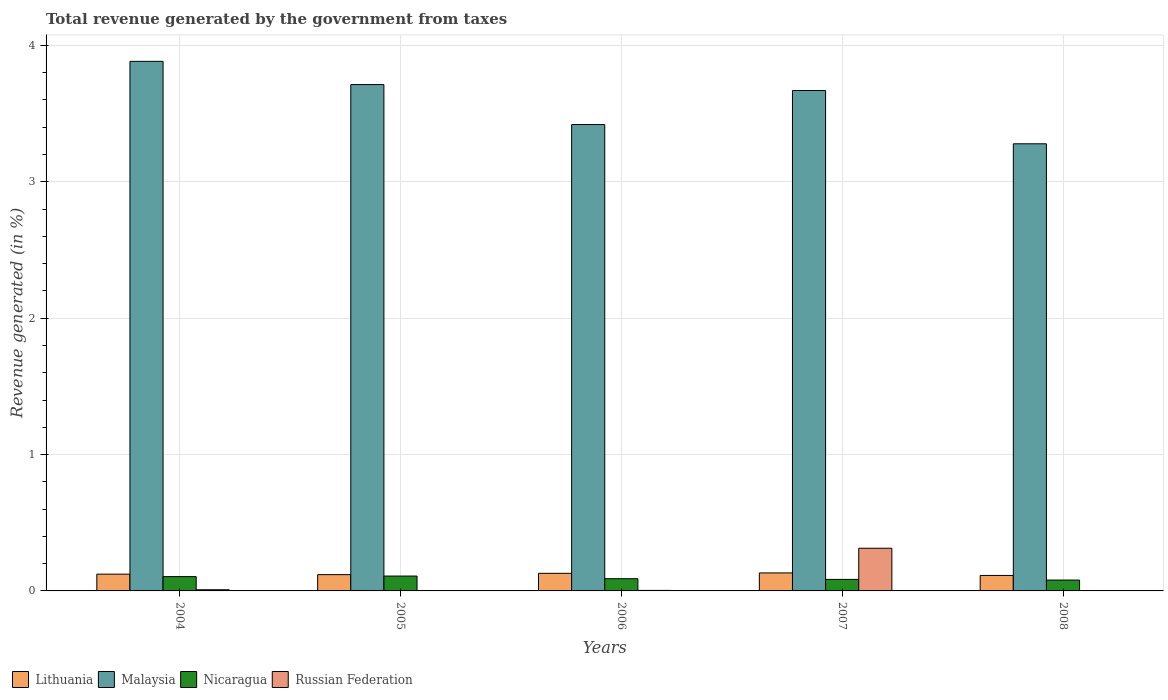How many different coloured bars are there?
Your answer should be very brief. 4. Are the number of bars per tick equal to the number of legend labels?
Your response must be concise. Yes. What is the label of the 1st group of bars from the left?
Your answer should be very brief. 2004. In how many cases, is the number of bars for a given year not equal to the number of legend labels?
Give a very brief answer. 0. What is the total revenue generated in Nicaragua in 2007?
Make the answer very short. 0.08. Across all years, what is the maximum total revenue generated in Russian Federation?
Give a very brief answer. 0.31. Across all years, what is the minimum total revenue generated in Lithuania?
Provide a succinct answer. 0.11. What is the total total revenue generated in Nicaragua in the graph?
Provide a succinct answer. 0.47. What is the difference between the total revenue generated in Lithuania in 2004 and that in 2008?
Your response must be concise. 0.01. What is the difference between the total revenue generated in Russian Federation in 2008 and the total revenue generated in Malaysia in 2007?
Give a very brief answer. -3.67. What is the average total revenue generated in Nicaragua per year?
Offer a terse response. 0.09. In the year 2005, what is the difference between the total revenue generated in Malaysia and total revenue generated in Lithuania?
Give a very brief answer. 3.59. In how many years, is the total revenue generated in Lithuania greater than 1.6 %?
Offer a very short reply. 0. What is the ratio of the total revenue generated in Nicaragua in 2004 to that in 2006?
Your response must be concise. 1.17. Is the difference between the total revenue generated in Malaysia in 2005 and 2007 greater than the difference between the total revenue generated in Lithuania in 2005 and 2007?
Ensure brevity in your answer.  Yes. What is the difference between the highest and the second highest total revenue generated in Lithuania?
Make the answer very short. 0. What is the difference between the highest and the lowest total revenue generated in Lithuania?
Your answer should be very brief. 0.02. In how many years, is the total revenue generated in Nicaragua greater than the average total revenue generated in Nicaragua taken over all years?
Make the answer very short. 2. What does the 3rd bar from the left in 2004 represents?
Ensure brevity in your answer.  Nicaragua. What does the 2nd bar from the right in 2004 represents?
Keep it short and to the point. Nicaragua. How many bars are there?
Your response must be concise. 20. Are all the bars in the graph horizontal?
Give a very brief answer. No. How many years are there in the graph?
Make the answer very short. 5. Are the values on the major ticks of Y-axis written in scientific E-notation?
Your answer should be compact. No. Does the graph contain any zero values?
Make the answer very short. No. Does the graph contain grids?
Your answer should be compact. Yes. Where does the legend appear in the graph?
Provide a succinct answer. Bottom left. How are the legend labels stacked?
Make the answer very short. Horizontal. What is the title of the graph?
Keep it short and to the point. Total revenue generated by the government from taxes. What is the label or title of the X-axis?
Your response must be concise. Years. What is the label or title of the Y-axis?
Give a very brief answer. Revenue generated (in %). What is the Revenue generated (in %) of Lithuania in 2004?
Make the answer very short. 0.12. What is the Revenue generated (in %) in Malaysia in 2004?
Ensure brevity in your answer.  3.88. What is the Revenue generated (in %) of Nicaragua in 2004?
Offer a very short reply. 0.1. What is the Revenue generated (in %) of Russian Federation in 2004?
Your answer should be compact. 0.01. What is the Revenue generated (in %) in Lithuania in 2005?
Give a very brief answer. 0.12. What is the Revenue generated (in %) in Malaysia in 2005?
Give a very brief answer. 3.71. What is the Revenue generated (in %) in Nicaragua in 2005?
Your answer should be compact. 0.11. What is the Revenue generated (in %) in Russian Federation in 2005?
Your answer should be compact. 0. What is the Revenue generated (in %) of Lithuania in 2006?
Give a very brief answer. 0.13. What is the Revenue generated (in %) in Malaysia in 2006?
Ensure brevity in your answer.  3.42. What is the Revenue generated (in %) of Nicaragua in 2006?
Your answer should be compact. 0.09. What is the Revenue generated (in %) of Russian Federation in 2006?
Your response must be concise. 0. What is the Revenue generated (in %) in Lithuania in 2007?
Your answer should be compact. 0.13. What is the Revenue generated (in %) of Malaysia in 2007?
Provide a short and direct response. 3.67. What is the Revenue generated (in %) of Nicaragua in 2007?
Your response must be concise. 0.08. What is the Revenue generated (in %) in Russian Federation in 2007?
Offer a very short reply. 0.31. What is the Revenue generated (in %) in Lithuania in 2008?
Offer a terse response. 0.11. What is the Revenue generated (in %) of Malaysia in 2008?
Provide a short and direct response. 3.28. What is the Revenue generated (in %) of Nicaragua in 2008?
Your answer should be very brief. 0.08. What is the Revenue generated (in %) of Russian Federation in 2008?
Ensure brevity in your answer.  0. Across all years, what is the maximum Revenue generated (in %) in Lithuania?
Make the answer very short. 0.13. Across all years, what is the maximum Revenue generated (in %) of Malaysia?
Provide a short and direct response. 3.88. Across all years, what is the maximum Revenue generated (in %) in Nicaragua?
Give a very brief answer. 0.11. Across all years, what is the maximum Revenue generated (in %) of Russian Federation?
Make the answer very short. 0.31. Across all years, what is the minimum Revenue generated (in %) of Lithuania?
Your response must be concise. 0.11. Across all years, what is the minimum Revenue generated (in %) in Malaysia?
Make the answer very short. 3.28. Across all years, what is the minimum Revenue generated (in %) in Nicaragua?
Your answer should be compact. 0.08. Across all years, what is the minimum Revenue generated (in %) of Russian Federation?
Your answer should be very brief. 0. What is the total Revenue generated (in %) in Lithuania in the graph?
Ensure brevity in your answer.  0.62. What is the total Revenue generated (in %) of Malaysia in the graph?
Keep it short and to the point. 17.96. What is the total Revenue generated (in %) in Nicaragua in the graph?
Give a very brief answer. 0.47. What is the total Revenue generated (in %) of Russian Federation in the graph?
Your answer should be compact. 0.33. What is the difference between the Revenue generated (in %) of Lithuania in 2004 and that in 2005?
Keep it short and to the point. 0. What is the difference between the Revenue generated (in %) in Malaysia in 2004 and that in 2005?
Offer a terse response. 0.17. What is the difference between the Revenue generated (in %) in Nicaragua in 2004 and that in 2005?
Ensure brevity in your answer.  -0. What is the difference between the Revenue generated (in %) of Russian Federation in 2004 and that in 2005?
Ensure brevity in your answer.  0.01. What is the difference between the Revenue generated (in %) of Lithuania in 2004 and that in 2006?
Keep it short and to the point. -0.01. What is the difference between the Revenue generated (in %) of Malaysia in 2004 and that in 2006?
Your answer should be compact. 0.46. What is the difference between the Revenue generated (in %) in Nicaragua in 2004 and that in 2006?
Ensure brevity in your answer.  0.02. What is the difference between the Revenue generated (in %) of Russian Federation in 2004 and that in 2006?
Offer a terse response. 0. What is the difference between the Revenue generated (in %) of Lithuania in 2004 and that in 2007?
Your answer should be very brief. -0.01. What is the difference between the Revenue generated (in %) of Malaysia in 2004 and that in 2007?
Offer a very short reply. 0.21. What is the difference between the Revenue generated (in %) in Nicaragua in 2004 and that in 2007?
Your answer should be compact. 0.02. What is the difference between the Revenue generated (in %) of Russian Federation in 2004 and that in 2007?
Offer a very short reply. -0.3. What is the difference between the Revenue generated (in %) in Lithuania in 2004 and that in 2008?
Your response must be concise. 0.01. What is the difference between the Revenue generated (in %) in Malaysia in 2004 and that in 2008?
Ensure brevity in your answer.  0.6. What is the difference between the Revenue generated (in %) of Nicaragua in 2004 and that in 2008?
Provide a succinct answer. 0.03. What is the difference between the Revenue generated (in %) in Russian Federation in 2004 and that in 2008?
Offer a very short reply. 0.01. What is the difference between the Revenue generated (in %) of Lithuania in 2005 and that in 2006?
Provide a succinct answer. -0.01. What is the difference between the Revenue generated (in %) in Malaysia in 2005 and that in 2006?
Ensure brevity in your answer.  0.29. What is the difference between the Revenue generated (in %) in Nicaragua in 2005 and that in 2006?
Offer a terse response. 0.02. What is the difference between the Revenue generated (in %) of Russian Federation in 2005 and that in 2006?
Your answer should be very brief. -0. What is the difference between the Revenue generated (in %) in Lithuania in 2005 and that in 2007?
Your response must be concise. -0.01. What is the difference between the Revenue generated (in %) in Malaysia in 2005 and that in 2007?
Keep it short and to the point. 0.04. What is the difference between the Revenue generated (in %) of Nicaragua in 2005 and that in 2007?
Make the answer very short. 0.02. What is the difference between the Revenue generated (in %) of Russian Federation in 2005 and that in 2007?
Keep it short and to the point. -0.31. What is the difference between the Revenue generated (in %) of Lithuania in 2005 and that in 2008?
Your answer should be compact. 0.01. What is the difference between the Revenue generated (in %) of Malaysia in 2005 and that in 2008?
Your response must be concise. 0.43. What is the difference between the Revenue generated (in %) in Nicaragua in 2005 and that in 2008?
Your answer should be very brief. 0.03. What is the difference between the Revenue generated (in %) in Russian Federation in 2005 and that in 2008?
Offer a terse response. -0. What is the difference between the Revenue generated (in %) of Lithuania in 2006 and that in 2007?
Provide a short and direct response. -0. What is the difference between the Revenue generated (in %) of Malaysia in 2006 and that in 2007?
Keep it short and to the point. -0.25. What is the difference between the Revenue generated (in %) in Nicaragua in 2006 and that in 2007?
Offer a terse response. 0.01. What is the difference between the Revenue generated (in %) of Russian Federation in 2006 and that in 2007?
Provide a succinct answer. -0.31. What is the difference between the Revenue generated (in %) in Lithuania in 2006 and that in 2008?
Keep it short and to the point. 0.02. What is the difference between the Revenue generated (in %) of Malaysia in 2006 and that in 2008?
Your answer should be very brief. 0.14. What is the difference between the Revenue generated (in %) of Nicaragua in 2006 and that in 2008?
Your answer should be compact. 0.01. What is the difference between the Revenue generated (in %) of Russian Federation in 2006 and that in 2008?
Your answer should be very brief. 0. What is the difference between the Revenue generated (in %) of Lithuania in 2007 and that in 2008?
Offer a very short reply. 0.02. What is the difference between the Revenue generated (in %) of Malaysia in 2007 and that in 2008?
Ensure brevity in your answer.  0.39. What is the difference between the Revenue generated (in %) of Nicaragua in 2007 and that in 2008?
Provide a short and direct response. 0. What is the difference between the Revenue generated (in %) in Russian Federation in 2007 and that in 2008?
Provide a succinct answer. 0.31. What is the difference between the Revenue generated (in %) in Lithuania in 2004 and the Revenue generated (in %) in Malaysia in 2005?
Offer a very short reply. -3.59. What is the difference between the Revenue generated (in %) of Lithuania in 2004 and the Revenue generated (in %) of Nicaragua in 2005?
Offer a very short reply. 0.01. What is the difference between the Revenue generated (in %) in Lithuania in 2004 and the Revenue generated (in %) in Russian Federation in 2005?
Keep it short and to the point. 0.12. What is the difference between the Revenue generated (in %) of Malaysia in 2004 and the Revenue generated (in %) of Nicaragua in 2005?
Offer a very short reply. 3.77. What is the difference between the Revenue generated (in %) in Malaysia in 2004 and the Revenue generated (in %) in Russian Federation in 2005?
Keep it short and to the point. 3.88. What is the difference between the Revenue generated (in %) in Nicaragua in 2004 and the Revenue generated (in %) in Russian Federation in 2005?
Provide a succinct answer. 0.1. What is the difference between the Revenue generated (in %) in Lithuania in 2004 and the Revenue generated (in %) in Malaysia in 2006?
Offer a very short reply. -3.3. What is the difference between the Revenue generated (in %) of Lithuania in 2004 and the Revenue generated (in %) of Nicaragua in 2006?
Offer a terse response. 0.03. What is the difference between the Revenue generated (in %) of Lithuania in 2004 and the Revenue generated (in %) of Russian Federation in 2006?
Offer a very short reply. 0.12. What is the difference between the Revenue generated (in %) of Malaysia in 2004 and the Revenue generated (in %) of Nicaragua in 2006?
Your answer should be compact. 3.79. What is the difference between the Revenue generated (in %) in Malaysia in 2004 and the Revenue generated (in %) in Russian Federation in 2006?
Offer a terse response. 3.88. What is the difference between the Revenue generated (in %) in Nicaragua in 2004 and the Revenue generated (in %) in Russian Federation in 2006?
Ensure brevity in your answer.  0.1. What is the difference between the Revenue generated (in %) in Lithuania in 2004 and the Revenue generated (in %) in Malaysia in 2007?
Offer a terse response. -3.55. What is the difference between the Revenue generated (in %) in Lithuania in 2004 and the Revenue generated (in %) in Nicaragua in 2007?
Ensure brevity in your answer.  0.04. What is the difference between the Revenue generated (in %) in Lithuania in 2004 and the Revenue generated (in %) in Russian Federation in 2007?
Your answer should be compact. -0.19. What is the difference between the Revenue generated (in %) of Malaysia in 2004 and the Revenue generated (in %) of Nicaragua in 2007?
Your answer should be compact. 3.8. What is the difference between the Revenue generated (in %) in Malaysia in 2004 and the Revenue generated (in %) in Russian Federation in 2007?
Keep it short and to the point. 3.57. What is the difference between the Revenue generated (in %) in Nicaragua in 2004 and the Revenue generated (in %) in Russian Federation in 2007?
Your response must be concise. -0.21. What is the difference between the Revenue generated (in %) of Lithuania in 2004 and the Revenue generated (in %) of Malaysia in 2008?
Keep it short and to the point. -3.16. What is the difference between the Revenue generated (in %) in Lithuania in 2004 and the Revenue generated (in %) in Nicaragua in 2008?
Your answer should be compact. 0.04. What is the difference between the Revenue generated (in %) of Lithuania in 2004 and the Revenue generated (in %) of Russian Federation in 2008?
Provide a short and direct response. 0.12. What is the difference between the Revenue generated (in %) of Malaysia in 2004 and the Revenue generated (in %) of Nicaragua in 2008?
Provide a succinct answer. 3.8. What is the difference between the Revenue generated (in %) in Malaysia in 2004 and the Revenue generated (in %) in Russian Federation in 2008?
Your answer should be compact. 3.88. What is the difference between the Revenue generated (in %) of Nicaragua in 2004 and the Revenue generated (in %) of Russian Federation in 2008?
Ensure brevity in your answer.  0.1. What is the difference between the Revenue generated (in %) in Lithuania in 2005 and the Revenue generated (in %) in Malaysia in 2006?
Provide a succinct answer. -3.3. What is the difference between the Revenue generated (in %) in Lithuania in 2005 and the Revenue generated (in %) in Nicaragua in 2006?
Your answer should be very brief. 0.03. What is the difference between the Revenue generated (in %) in Lithuania in 2005 and the Revenue generated (in %) in Russian Federation in 2006?
Give a very brief answer. 0.12. What is the difference between the Revenue generated (in %) of Malaysia in 2005 and the Revenue generated (in %) of Nicaragua in 2006?
Keep it short and to the point. 3.62. What is the difference between the Revenue generated (in %) in Malaysia in 2005 and the Revenue generated (in %) in Russian Federation in 2006?
Give a very brief answer. 3.71. What is the difference between the Revenue generated (in %) in Nicaragua in 2005 and the Revenue generated (in %) in Russian Federation in 2006?
Make the answer very short. 0.11. What is the difference between the Revenue generated (in %) of Lithuania in 2005 and the Revenue generated (in %) of Malaysia in 2007?
Give a very brief answer. -3.55. What is the difference between the Revenue generated (in %) of Lithuania in 2005 and the Revenue generated (in %) of Nicaragua in 2007?
Ensure brevity in your answer.  0.03. What is the difference between the Revenue generated (in %) of Lithuania in 2005 and the Revenue generated (in %) of Russian Federation in 2007?
Give a very brief answer. -0.19. What is the difference between the Revenue generated (in %) of Malaysia in 2005 and the Revenue generated (in %) of Nicaragua in 2007?
Your answer should be compact. 3.63. What is the difference between the Revenue generated (in %) of Malaysia in 2005 and the Revenue generated (in %) of Russian Federation in 2007?
Offer a very short reply. 3.4. What is the difference between the Revenue generated (in %) in Nicaragua in 2005 and the Revenue generated (in %) in Russian Federation in 2007?
Make the answer very short. -0.2. What is the difference between the Revenue generated (in %) of Lithuania in 2005 and the Revenue generated (in %) of Malaysia in 2008?
Give a very brief answer. -3.16. What is the difference between the Revenue generated (in %) in Lithuania in 2005 and the Revenue generated (in %) in Nicaragua in 2008?
Make the answer very short. 0.04. What is the difference between the Revenue generated (in %) of Lithuania in 2005 and the Revenue generated (in %) of Russian Federation in 2008?
Provide a short and direct response. 0.12. What is the difference between the Revenue generated (in %) in Malaysia in 2005 and the Revenue generated (in %) in Nicaragua in 2008?
Offer a very short reply. 3.63. What is the difference between the Revenue generated (in %) in Malaysia in 2005 and the Revenue generated (in %) in Russian Federation in 2008?
Keep it short and to the point. 3.71. What is the difference between the Revenue generated (in %) of Nicaragua in 2005 and the Revenue generated (in %) of Russian Federation in 2008?
Offer a terse response. 0.11. What is the difference between the Revenue generated (in %) of Lithuania in 2006 and the Revenue generated (in %) of Malaysia in 2007?
Give a very brief answer. -3.54. What is the difference between the Revenue generated (in %) of Lithuania in 2006 and the Revenue generated (in %) of Nicaragua in 2007?
Make the answer very short. 0.04. What is the difference between the Revenue generated (in %) of Lithuania in 2006 and the Revenue generated (in %) of Russian Federation in 2007?
Keep it short and to the point. -0.18. What is the difference between the Revenue generated (in %) of Malaysia in 2006 and the Revenue generated (in %) of Nicaragua in 2007?
Keep it short and to the point. 3.34. What is the difference between the Revenue generated (in %) in Malaysia in 2006 and the Revenue generated (in %) in Russian Federation in 2007?
Keep it short and to the point. 3.11. What is the difference between the Revenue generated (in %) of Nicaragua in 2006 and the Revenue generated (in %) of Russian Federation in 2007?
Provide a succinct answer. -0.22. What is the difference between the Revenue generated (in %) in Lithuania in 2006 and the Revenue generated (in %) in Malaysia in 2008?
Keep it short and to the point. -3.15. What is the difference between the Revenue generated (in %) in Lithuania in 2006 and the Revenue generated (in %) in Nicaragua in 2008?
Make the answer very short. 0.05. What is the difference between the Revenue generated (in %) of Lithuania in 2006 and the Revenue generated (in %) of Russian Federation in 2008?
Make the answer very short. 0.13. What is the difference between the Revenue generated (in %) of Malaysia in 2006 and the Revenue generated (in %) of Nicaragua in 2008?
Your response must be concise. 3.34. What is the difference between the Revenue generated (in %) of Malaysia in 2006 and the Revenue generated (in %) of Russian Federation in 2008?
Your response must be concise. 3.42. What is the difference between the Revenue generated (in %) in Nicaragua in 2006 and the Revenue generated (in %) in Russian Federation in 2008?
Give a very brief answer. 0.09. What is the difference between the Revenue generated (in %) in Lithuania in 2007 and the Revenue generated (in %) in Malaysia in 2008?
Provide a succinct answer. -3.15. What is the difference between the Revenue generated (in %) of Lithuania in 2007 and the Revenue generated (in %) of Nicaragua in 2008?
Offer a very short reply. 0.05. What is the difference between the Revenue generated (in %) of Lithuania in 2007 and the Revenue generated (in %) of Russian Federation in 2008?
Your answer should be very brief. 0.13. What is the difference between the Revenue generated (in %) of Malaysia in 2007 and the Revenue generated (in %) of Nicaragua in 2008?
Provide a short and direct response. 3.59. What is the difference between the Revenue generated (in %) in Malaysia in 2007 and the Revenue generated (in %) in Russian Federation in 2008?
Provide a succinct answer. 3.67. What is the difference between the Revenue generated (in %) of Nicaragua in 2007 and the Revenue generated (in %) of Russian Federation in 2008?
Your response must be concise. 0.08. What is the average Revenue generated (in %) in Lithuania per year?
Make the answer very short. 0.12. What is the average Revenue generated (in %) in Malaysia per year?
Give a very brief answer. 3.59. What is the average Revenue generated (in %) of Nicaragua per year?
Your answer should be compact. 0.09. What is the average Revenue generated (in %) in Russian Federation per year?
Your response must be concise. 0.07. In the year 2004, what is the difference between the Revenue generated (in %) of Lithuania and Revenue generated (in %) of Malaysia?
Offer a very short reply. -3.76. In the year 2004, what is the difference between the Revenue generated (in %) of Lithuania and Revenue generated (in %) of Nicaragua?
Your answer should be very brief. 0.02. In the year 2004, what is the difference between the Revenue generated (in %) of Lithuania and Revenue generated (in %) of Russian Federation?
Ensure brevity in your answer.  0.11. In the year 2004, what is the difference between the Revenue generated (in %) of Malaysia and Revenue generated (in %) of Nicaragua?
Make the answer very short. 3.78. In the year 2004, what is the difference between the Revenue generated (in %) in Malaysia and Revenue generated (in %) in Russian Federation?
Give a very brief answer. 3.87. In the year 2004, what is the difference between the Revenue generated (in %) in Nicaragua and Revenue generated (in %) in Russian Federation?
Your answer should be compact. 0.1. In the year 2005, what is the difference between the Revenue generated (in %) of Lithuania and Revenue generated (in %) of Malaysia?
Give a very brief answer. -3.59. In the year 2005, what is the difference between the Revenue generated (in %) in Lithuania and Revenue generated (in %) in Nicaragua?
Provide a succinct answer. 0.01. In the year 2005, what is the difference between the Revenue generated (in %) of Lithuania and Revenue generated (in %) of Russian Federation?
Your answer should be compact. 0.12. In the year 2005, what is the difference between the Revenue generated (in %) in Malaysia and Revenue generated (in %) in Nicaragua?
Give a very brief answer. 3.6. In the year 2005, what is the difference between the Revenue generated (in %) in Malaysia and Revenue generated (in %) in Russian Federation?
Offer a terse response. 3.71. In the year 2005, what is the difference between the Revenue generated (in %) of Nicaragua and Revenue generated (in %) of Russian Federation?
Provide a succinct answer. 0.11. In the year 2006, what is the difference between the Revenue generated (in %) in Lithuania and Revenue generated (in %) in Malaysia?
Your answer should be compact. -3.29. In the year 2006, what is the difference between the Revenue generated (in %) in Lithuania and Revenue generated (in %) in Nicaragua?
Offer a terse response. 0.04. In the year 2006, what is the difference between the Revenue generated (in %) in Lithuania and Revenue generated (in %) in Russian Federation?
Ensure brevity in your answer.  0.13. In the year 2006, what is the difference between the Revenue generated (in %) in Malaysia and Revenue generated (in %) in Nicaragua?
Offer a very short reply. 3.33. In the year 2006, what is the difference between the Revenue generated (in %) of Malaysia and Revenue generated (in %) of Russian Federation?
Make the answer very short. 3.42. In the year 2006, what is the difference between the Revenue generated (in %) in Nicaragua and Revenue generated (in %) in Russian Federation?
Offer a terse response. 0.09. In the year 2007, what is the difference between the Revenue generated (in %) of Lithuania and Revenue generated (in %) of Malaysia?
Give a very brief answer. -3.54. In the year 2007, what is the difference between the Revenue generated (in %) of Lithuania and Revenue generated (in %) of Nicaragua?
Your response must be concise. 0.05. In the year 2007, what is the difference between the Revenue generated (in %) of Lithuania and Revenue generated (in %) of Russian Federation?
Ensure brevity in your answer.  -0.18. In the year 2007, what is the difference between the Revenue generated (in %) in Malaysia and Revenue generated (in %) in Nicaragua?
Your answer should be compact. 3.59. In the year 2007, what is the difference between the Revenue generated (in %) of Malaysia and Revenue generated (in %) of Russian Federation?
Your response must be concise. 3.36. In the year 2007, what is the difference between the Revenue generated (in %) of Nicaragua and Revenue generated (in %) of Russian Federation?
Provide a succinct answer. -0.23. In the year 2008, what is the difference between the Revenue generated (in %) in Lithuania and Revenue generated (in %) in Malaysia?
Keep it short and to the point. -3.17. In the year 2008, what is the difference between the Revenue generated (in %) of Lithuania and Revenue generated (in %) of Nicaragua?
Offer a terse response. 0.03. In the year 2008, what is the difference between the Revenue generated (in %) in Lithuania and Revenue generated (in %) in Russian Federation?
Provide a short and direct response. 0.11. In the year 2008, what is the difference between the Revenue generated (in %) in Malaysia and Revenue generated (in %) in Nicaragua?
Offer a very short reply. 3.2. In the year 2008, what is the difference between the Revenue generated (in %) in Malaysia and Revenue generated (in %) in Russian Federation?
Provide a succinct answer. 3.28. In the year 2008, what is the difference between the Revenue generated (in %) in Nicaragua and Revenue generated (in %) in Russian Federation?
Provide a short and direct response. 0.08. What is the ratio of the Revenue generated (in %) of Malaysia in 2004 to that in 2005?
Make the answer very short. 1.05. What is the ratio of the Revenue generated (in %) in Nicaragua in 2004 to that in 2005?
Your answer should be compact. 0.96. What is the ratio of the Revenue generated (in %) of Russian Federation in 2004 to that in 2005?
Offer a terse response. 7.78. What is the ratio of the Revenue generated (in %) in Lithuania in 2004 to that in 2006?
Offer a terse response. 0.95. What is the ratio of the Revenue generated (in %) in Malaysia in 2004 to that in 2006?
Ensure brevity in your answer.  1.14. What is the ratio of the Revenue generated (in %) in Nicaragua in 2004 to that in 2006?
Provide a short and direct response. 1.17. What is the ratio of the Revenue generated (in %) of Russian Federation in 2004 to that in 2006?
Make the answer very short. 2.29. What is the ratio of the Revenue generated (in %) of Lithuania in 2004 to that in 2007?
Make the answer very short. 0.93. What is the ratio of the Revenue generated (in %) of Malaysia in 2004 to that in 2007?
Make the answer very short. 1.06. What is the ratio of the Revenue generated (in %) of Nicaragua in 2004 to that in 2007?
Your answer should be very brief. 1.24. What is the ratio of the Revenue generated (in %) in Russian Federation in 2004 to that in 2007?
Ensure brevity in your answer.  0.03. What is the ratio of the Revenue generated (in %) in Lithuania in 2004 to that in 2008?
Provide a succinct answer. 1.08. What is the ratio of the Revenue generated (in %) in Malaysia in 2004 to that in 2008?
Offer a very short reply. 1.18. What is the ratio of the Revenue generated (in %) in Nicaragua in 2004 to that in 2008?
Your response must be concise. 1.31. What is the ratio of the Revenue generated (in %) in Russian Federation in 2004 to that in 2008?
Provide a short and direct response. 4.1. What is the ratio of the Revenue generated (in %) in Lithuania in 2005 to that in 2006?
Ensure brevity in your answer.  0.93. What is the ratio of the Revenue generated (in %) in Malaysia in 2005 to that in 2006?
Keep it short and to the point. 1.09. What is the ratio of the Revenue generated (in %) of Nicaragua in 2005 to that in 2006?
Your answer should be compact. 1.22. What is the ratio of the Revenue generated (in %) of Russian Federation in 2005 to that in 2006?
Keep it short and to the point. 0.29. What is the ratio of the Revenue generated (in %) of Lithuania in 2005 to that in 2007?
Offer a very short reply. 0.9. What is the ratio of the Revenue generated (in %) of Malaysia in 2005 to that in 2007?
Keep it short and to the point. 1.01. What is the ratio of the Revenue generated (in %) in Nicaragua in 2005 to that in 2007?
Make the answer very short. 1.29. What is the ratio of the Revenue generated (in %) of Russian Federation in 2005 to that in 2007?
Offer a very short reply. 0. What is the ratio of the Revenue generated (in %) of Lithuania in 2005 to that in 2008?
Your answer should be very brief. 1.05. What is the ratio of the Revenue generated (in %) in Malaysia in 2005 to that in 2008?
Offer a very short reply. 1.13. What is the ratio of the Revenue generated (in %) of Nicaragua in 2005 to that in 2008?
Offer a very short reply. 1.37. What is the ratio of the Revenue generated (in %) in Russian Federation in 2005 to that in 2008?
Offer a very short reply. 0.53. What is the ratio of the Revenue generated (in %) in Lithuania in 2006 to that in 2007?
Keep it short and to the point. 0.98. What is the ratio of the Revenue generated (in %) of Malaysia in 2006 to that in 2007?
Your answer should be compact. 0.93. What is the ratio of the Revenue generated (in %) in Nicaragua in 2006 to that in 2007?
Ensure brevity in your answer.  1.06. What is the ratio of the Revenue generated (in %) in Russian Federation in 2006 to that in 2007?
Your answer should be compact. 0.01. What is the ratio of the Revenue generated (in %) of Lithuania in 2006 to that in 2008?
Provide a succinct answer. 1.14. What is the ratio of the Revenue generated (in %) in Malaysia in 2006 to that in 2008?
Offer a terse response. 1.04. What is the ratio of the Revenue generated (in %) of Nicaragua in 2006 to that in 2008?
Your answer should be very brief. 1.12. What is the ratio of the Revenue generated (in %) in Russian Federation in 2006 to that in 2008?
Offer a very short reply. 1.79. What is the ratio of the Revenue generated (in %) of Lithuania in 2007 to that in 2008?
Give a very brief answer. 1.16. What is the ratio of the Revenue generated (in %) of Malaysia in 2007 to that in 2008?
Provide a short and direct response. 1.12. What is the ratio of the Revenue generated (in %) of Nicaragua in 2007 to that in 2008?
Give a very brief answer. 1.06. What is the ratio of the Revenue generated (in %) in Russian Federation in 2007 to that in 2008?
Ensure brevity in your answer.  147.39. What is the difference between the highest and the second highest Revenue generated (in %) in Lithuania?
Make the answer very short. 0. What is the difference between the highest and the second highest Revenue generated (in %) of Malaysia?
Provide a short and direct response. 0.17. What is the difference between the highest and the second highest Revenue generated (in %) of Nicaragua?
Make the answer very short. 0. What is the difference between the highest and the second highest Revenue generated (in %) of Russian Federation?
Your answer should be very brief. 0.3. What is the difference between the highest and the lowest Revenue generated (in %) in Lithuania?
Give a very brief answer. 0.02. What is the difference between the highest and the lowest Revenue generated (in %) in Malaysia?
Your response must be concise. 0.6. What is the difference between the highest and the lowest Revenue generated (in %) in Nicaragua?
Your response must be concise. 0.03. What is the difference between the highest and the lowest Revenue generated (in %) of Russian Federation?
Your answer should be very brief. 0.31. 